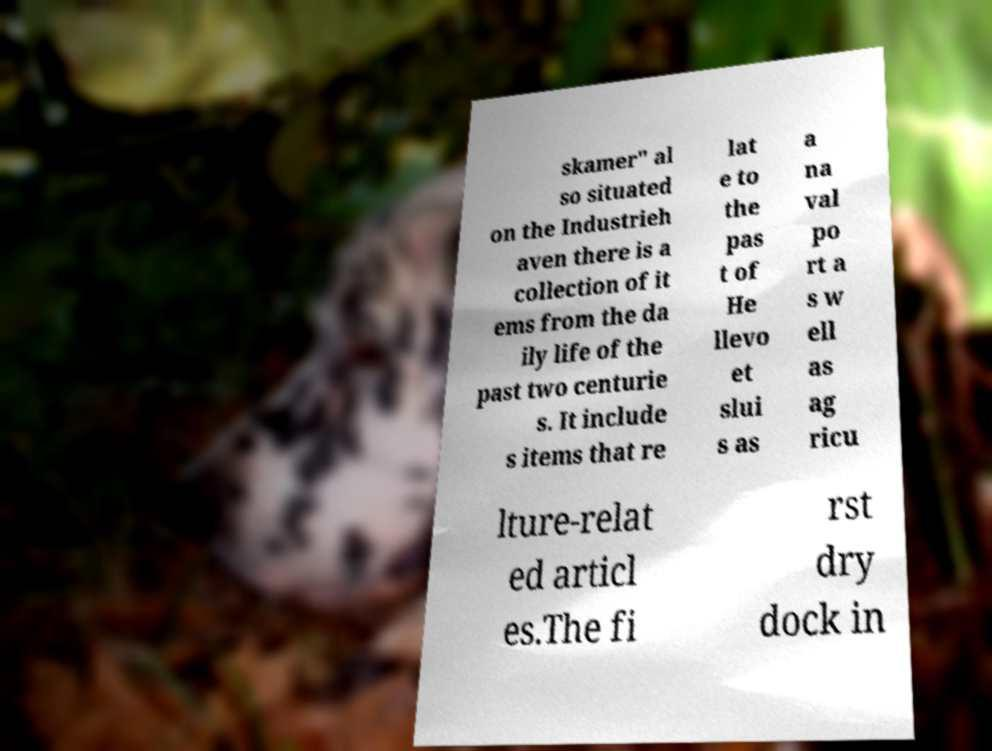Can you accurately transcribe the text from the provided image for me? skamer" al so situated on the Industrieh aven there is a collection of it ems from the da ily life of the past two centurie s. It include s items that re lat e to the pas t of He llevo et slui s as a na val po rt a s w ell as ag ricu lture-relat ed articl es.The fi rst dry dock in 